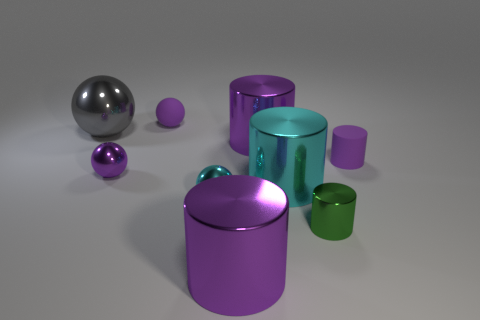What number of spheres are either gray matte objects or small purple objects?
Your answer should be compact. 2. There is a small matte thing on the right side of the large purple cylinder in front of the tiny purple cylinder that is to the right of the big metal ball; what is its shape?
Your response must be concise. Cylinder. There is a small metal thing that is the same color as the small rubber cylinder; what is its shape?
Your answer should be compact. Sphere. What number of cyan cubes are the same size as the matte sphere?
Provide a short and direct response. 0. Are there any purple matte spheres that are left of the tiny purple matte thing that is to the left of the small green cylinder?
Offer a very short reply. No. What number of objects are either large purple cylinders or cyan objects?
Ensure brevity in your answer.  4. The tiny cylinder that is behind the small sphere in front of the purple metallic thing that is to the left of the cyan metallic sphere is what color?
Make the answer very short. Purple. Is there anything else of the same color as the small matte cylinder?
Provide a succinct answer. Yes. Is the size of the cyan shiny sphere the same as the green object?
Provide a short and direct response. Yes. What number of objects are either tiny purple matte objects that are right of the small cyan thing or tiny purple spheres behind the gray metal object?
Provide a short and direct response. 2. 